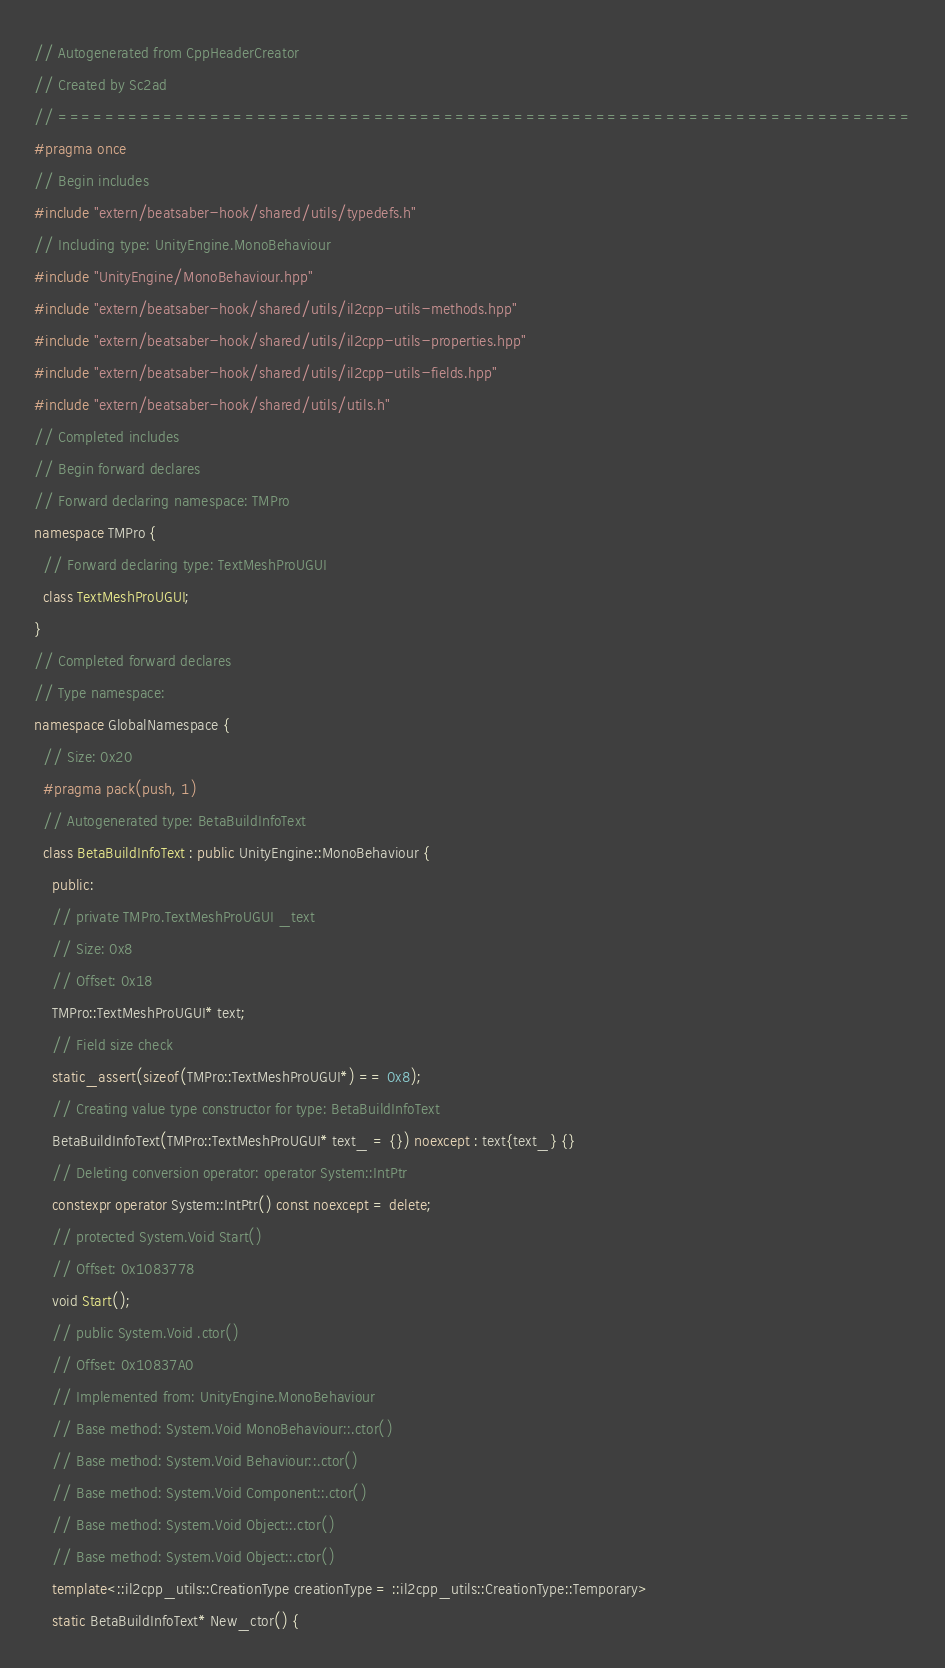<code> <loc_0><loc_0><loc_500><loc_500><_C++_>// Autogenerated from CppHeaderCreator
// Created by Sc2ad
// =========================================================================
#pragma once
// Begin includes
#include "extern/beatsaber-hook/shared/utils/typedefs.h"
// Including type: UnityEngine.MonoBehaviour
#include "UnityEngine/MonoBehaviour.hpp"
#include "extern/beatsaber-hook/shared/utils/il2cpp-utils-methods.hpp"
#include "extern/beatsaber-hook/shared/utils/il2cpp-utils-properties.hpp"
#include "extern/beatsaber-hook/shared/utils/il2cpp-utils-fields.hpp"
#include "extern/beatsaber-hook/shared/utils/utils.h"
// Completed includes
// Begin forward declares
// Forward declaring namespace: TMPro
namespace TMPro {
  // Forward declaring type: TextMeshProUGUI
  class TextMeshProUGUI;
}
// Completed forward declares
// Type namespace: 
namespace GlobalNamespace {
  // Size: 0x20
  #pragma pack(push, 1)
  // Autogenerated type: BetaBuildInfoText
  class BetaBuildInfoText : public UnityEngine::MonoBehaviour {
    public:
    // private TMPro.TextMeshProUGUI _text
    // Size: 0x8
    // Offset: 0x18
    TMPro::TextMeshProUGUI* text;
    // Field size check
    static_assert(sizeof(TMPro::TextMeshProUGUI*) == 0x8);
    // Creating value type constructor for type: BetaBuildInfoText
    BetaBuildInfoText(TMPro::TextMeshProUGUI* text_ = {}) noexcept : text{text_} {}
    // Deleting conversion operator: operator System::IntPtr
    constexpr operator System::IntPtr() const noexcept = delete;
    // protected System.Void Start()
    // Offset: 0x1083778
    void Start();
    // public System.Void .ctor()
    // Offset: 0x10837A0
    // Implemented from: UnityEngine.MonoBehaviour
    // Base method: System.Void MonoBehaviour::.ctor()
    // Base method: System.Void Behaviour::.ctor()
    // Base method: System.Void Component::.ctor()
    // Base method: System.Void Object::.ctor()
    // Base method: System.Void Object::.ctor()
    template<::il2cpp_utils::CreationType creationType = ::il2cpp_utils::CreationType::Temporary>
    static BetaBuildInfoText* New_ctor() {</code> 